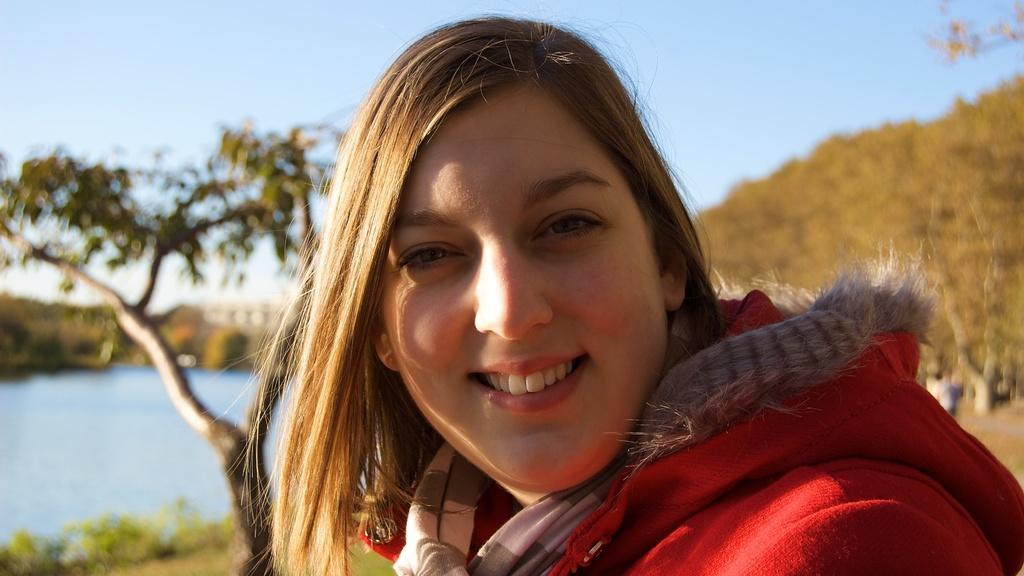Please provide a concise description of this image. This image consists of a woman in the middle. She is wearing a red coat. There are trees on the left side and right side. There is water on the left side. There is sky at the top. 